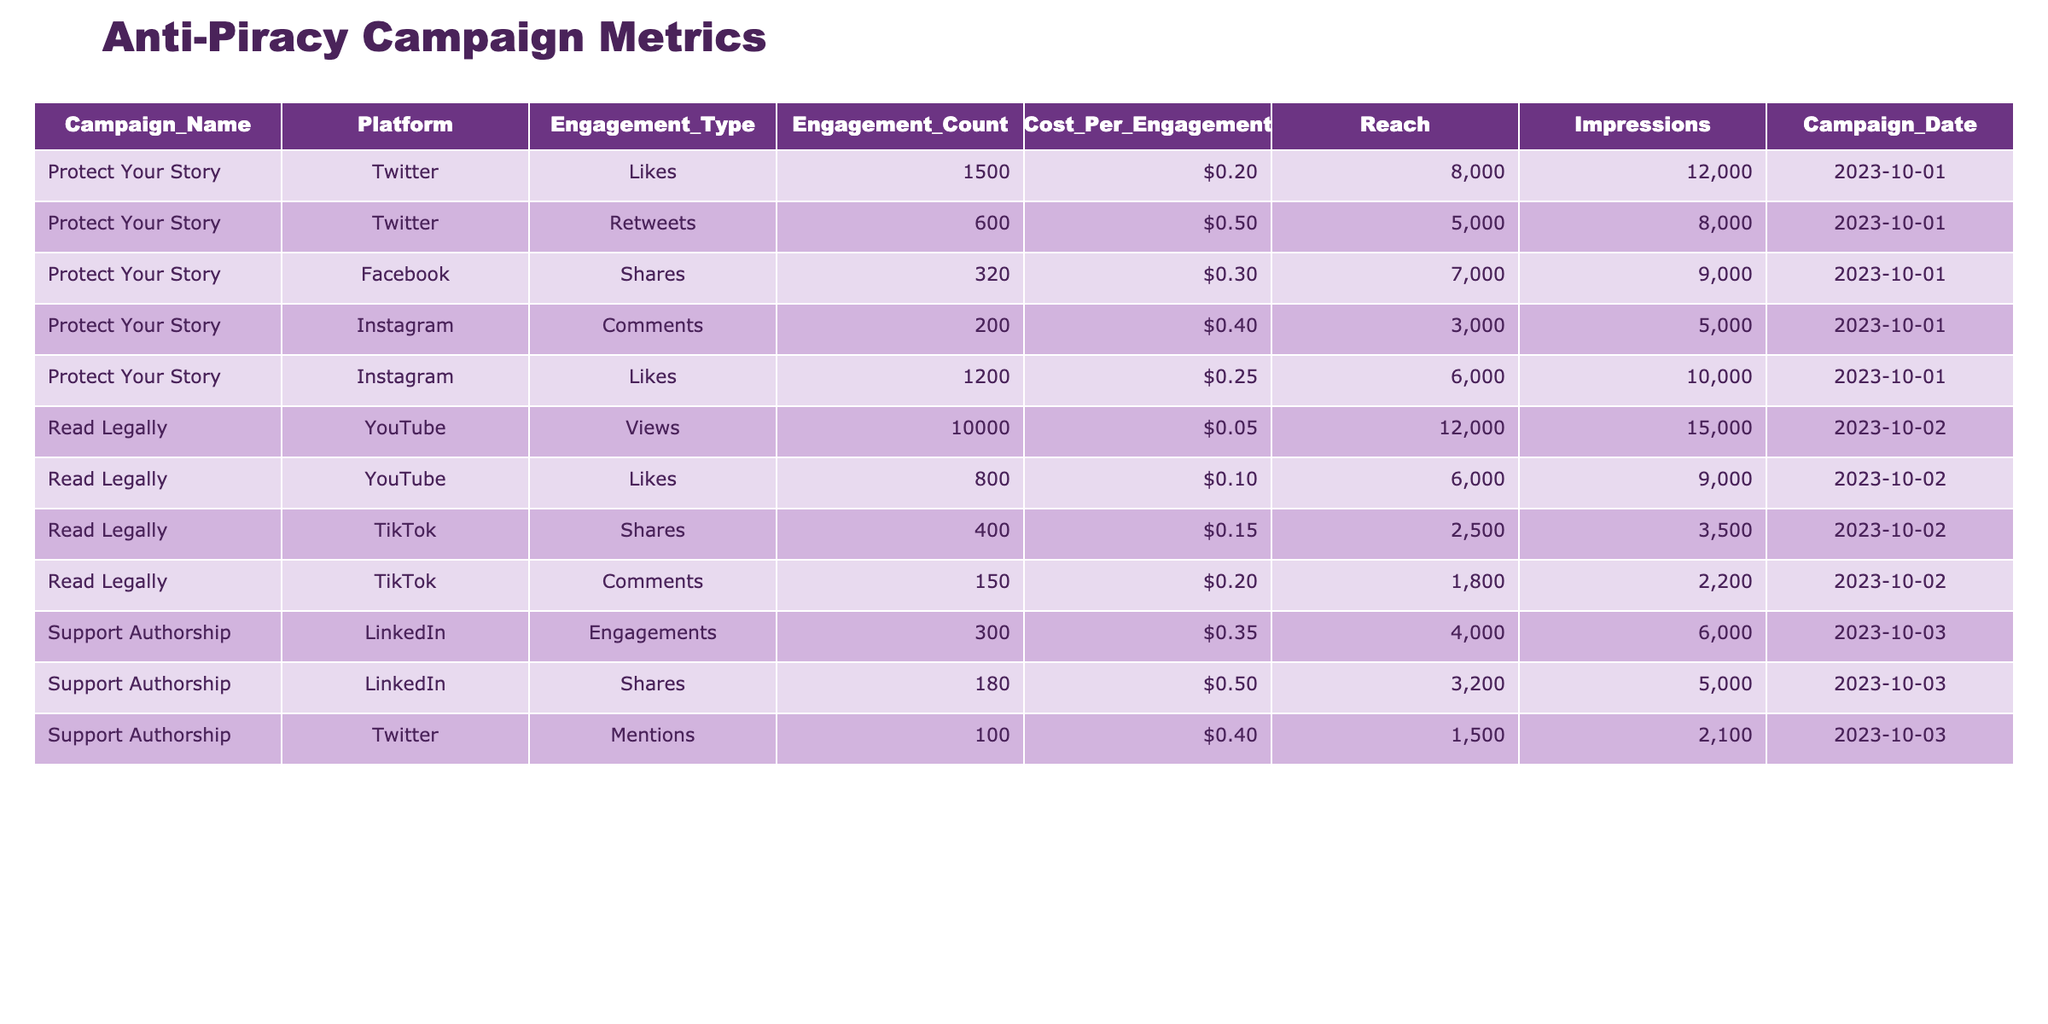What is the total engagement count for the "Protect Your Story" campaign on Twitter? The "Protect Your Story" campaign on Twitter includes Likes (1500) and Retweets (600), so we add these two numbers together: 1500 + 600 = 2100.
Answer: 2100 Which social media platform had the highest engagement count for the "Read Legally" campaign? The "Read Legally" campaign had 10000 Views on YouTube (the highest) compared to Likes (800) on YouTube and Shares (400) and Comments (150) on TikTok.
Answer: YouTube What is the average cost per engagement for the "Support Authorship" campaign across LinkedIn and Twitter? The cost per engagement for LinkedIn is $0.35 (300 engagements) and $0.40 (100 mentions) for Twitter, so we calculate the average as follows: ($0.35 + $0.40) / 2 = $0.375.
Answer: $0.38 Did the "Protect Your Story" campaign receive more engagements on Instagram than on Facebook? Total engagements on Instagram include Likes (1200) and Comments (200), which gives 1400. For Facebook, the total is just Shares (320). Since 1400 > 320, the statement is true.
Answer: Yes What is the total reach across all platforms for the "Read Legally" campaign? The reach for "Read Legally" includes 12000 from YouTube, 6000 from YouTube Likes, 2500 from TikTok Shares, and 1800 from TikTok Comments. Summing these: 12000 + 6000 + 2500 + 1800 = 22300.
Answer: 22300 What is the percentage of engagements from Instagram compared to total engagements for the "Protect Your Story" campaign? The total engagements for "Protect Your Story" is 1500 (Likes) + 600 (Retweets) + 320 (Shares) + 200 (Comments) + 1200 (Instagram Likes) = 3820. Instagram has 200 (Comments) + 1200 (Likes) = 1400 engagements. Therefore, the percentage is (1400 / 3820) * 100 = 36.6%.
Answer: 36.6% Which engagement type on Twitter had the highest cost per engagement? The "Protect Your Story" campaign on Twitter has Likes at $0.20 and Retweets at $0.50, making Retweets the highest cost per engagement.
Answer: Retweets How many more impressions did the "Read Legally" YouTube Views generate compared to TikTok Shares? YouTube Views generated 15000 impressions, while TikTok Shares generated 3500 impressions. Calculating the difference: 15000 - 3500 = 11500.
Answer: 11500 